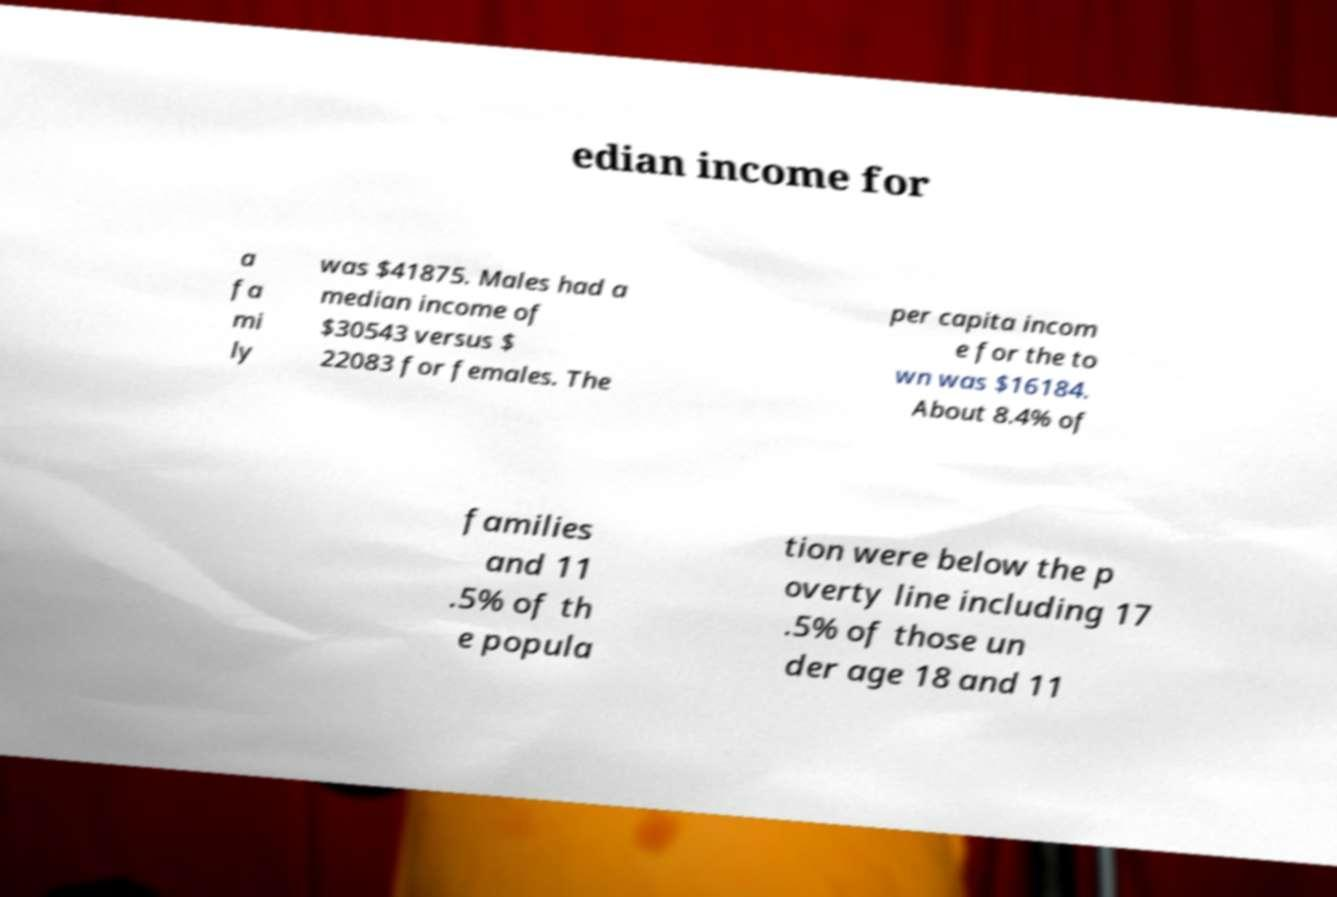Could you assist in decoding the text presented in this image and type it out clearly? edian income for a fa mi ly was $41875. Males had a median income of $30543 versus $ 22083 for females. The per capita incom e for the to wn was $16184. About 8.4% of families and 11 .5% of th e popula tion were below the p overty line including 17 .5% of those un der age 18 and 11 